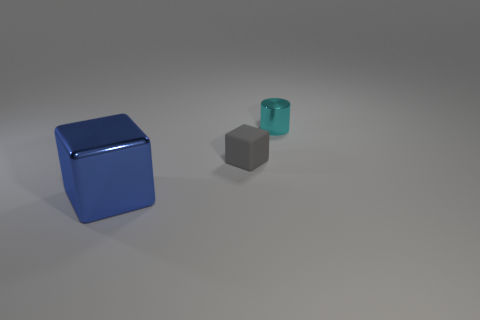Add 2 large yellow metallic cubes. How many objects exist? 5 Subtract all blocks. How many objects are left? 1 Subtract 1 cyan cylinders. How many objects are left? 2 Subtract all big cyan matte cylinders. Subtract all cylinders. How many objects are left? 2 Add 1 tiny cyan things. How many tiny cyan things are left? 2 Add 2 big yellow metallic blocks. How many big yellow metallic blocks exist? 2 